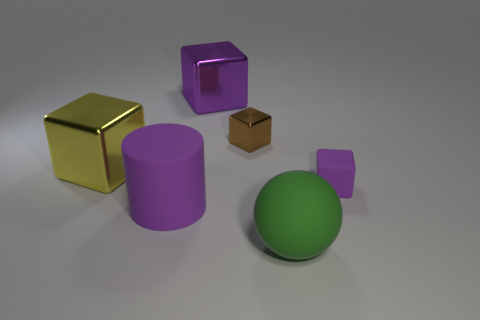Subtract all metallic blocks. How many blocks are left? 1 Subtract all yellow cylinders. How many purple cubes are left? 2 Subtract all brown cubes. How many cubes are left? 3 Subtract 2 cubes. How many cubes are left? 2 Add 2 brown shiny objects. How many objects exist? 8 Subtract all cylinders. How many objects are left? 5 Subtract all red cubes. Subtract all yellow cylinders. How many cubes are left? 4 Subtract 0 gray cubes. How many objects are left? 6 Subtract all cubes. Subtract all big rubber spheres. How many objects are left? 1 Add 6 blocks. How many blocks are left? 10 